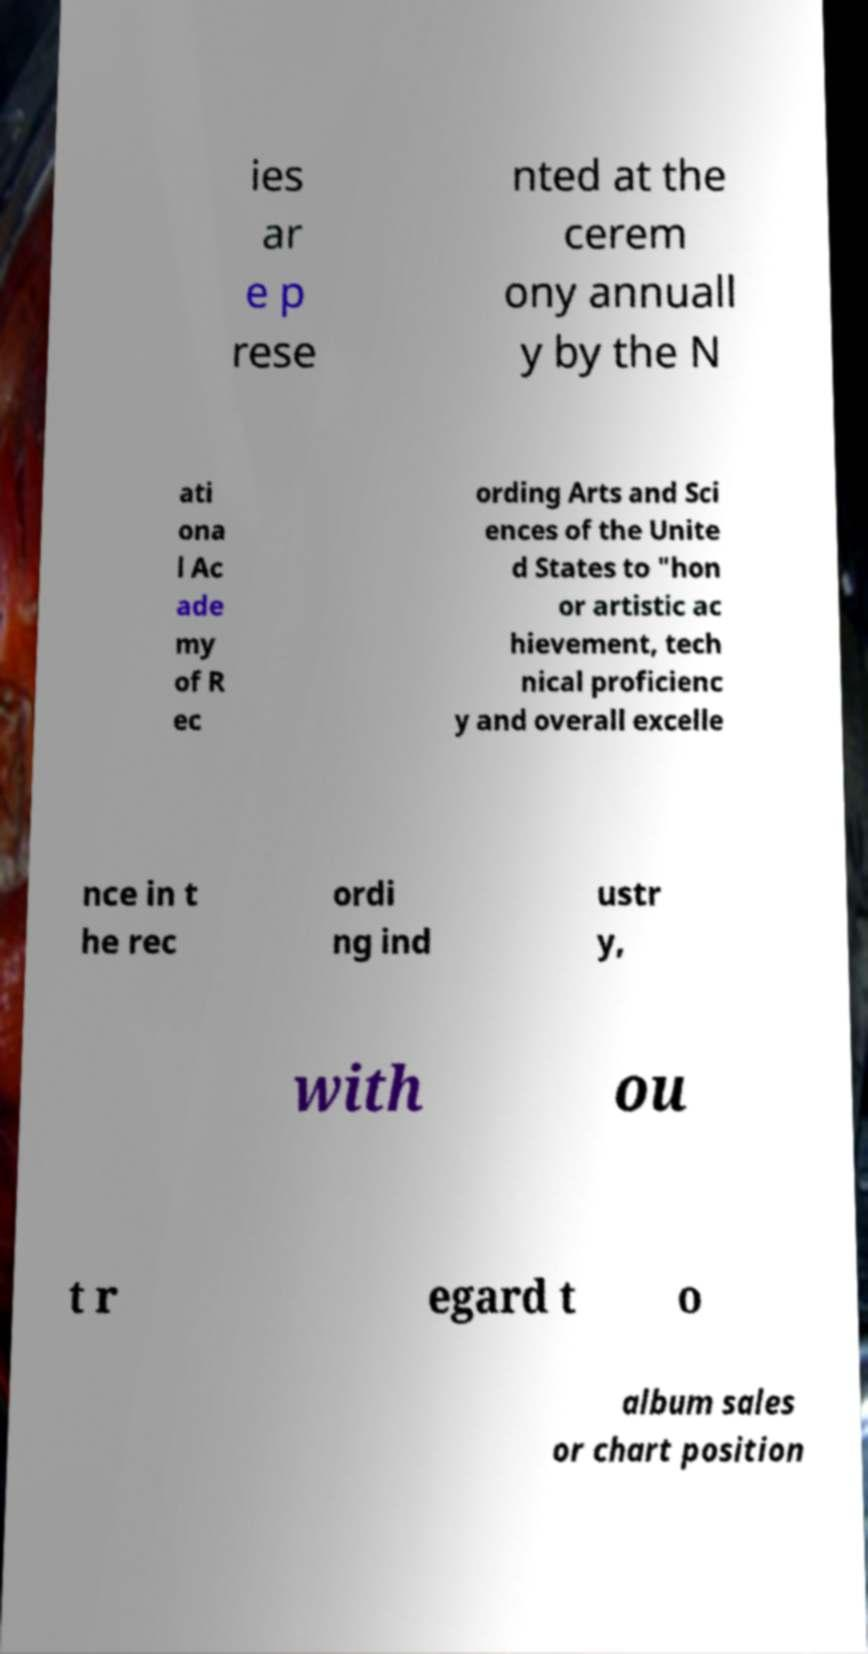For documentation purposes, I need the text within this image transcribed. Could you provide that? ies ar e p rese nted at the cerem ony annuall y by the N ati ona l Ac ade my of R ec ording Arts and Sci ences of the Unite d States to "hon or artistic ac hievement, tech nical proficienc y and overall excelle nce in t he rec ordi ng ind ustr y, with ou t r egard t o album sales or chart position 